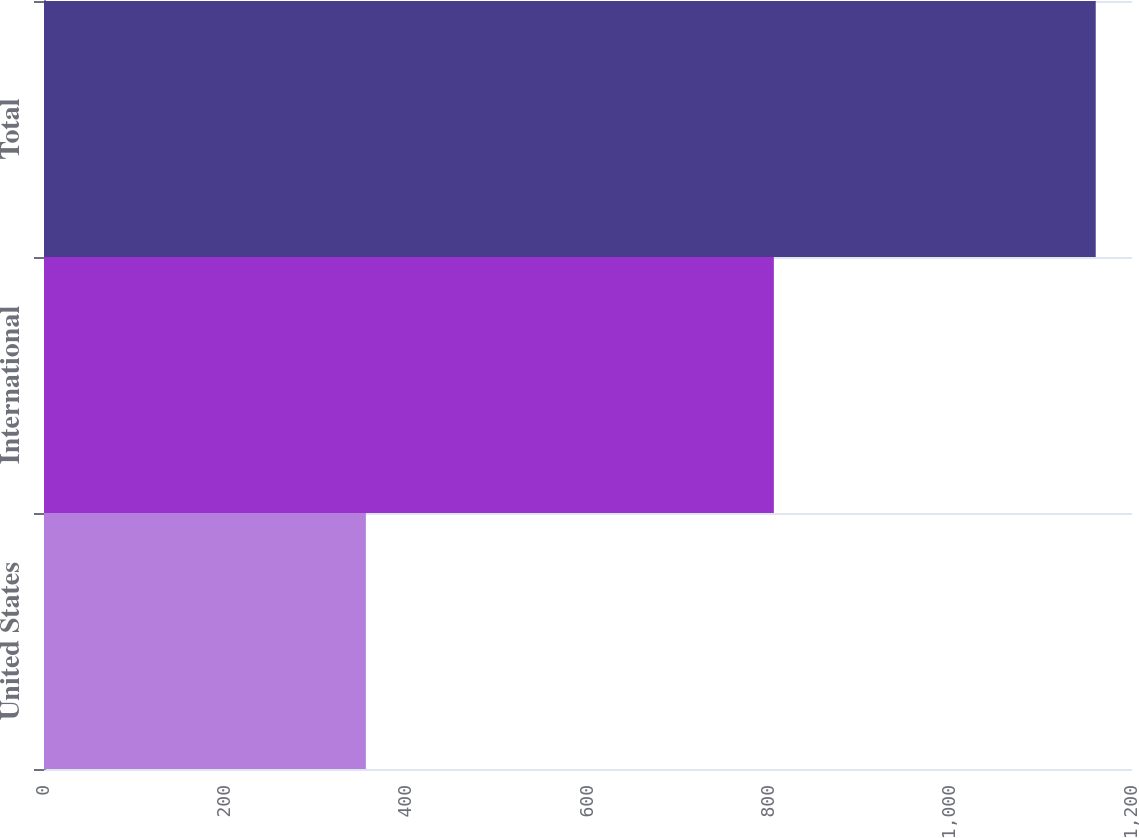Convert chart to OTSL. <chart><loc_0><loc_0><loc_500><loc_500><bar_chart><fcel>United States<fcel>International<fcel>Total<nl><fcel>355<fcel>805<fcel>1160<nl></chart> 